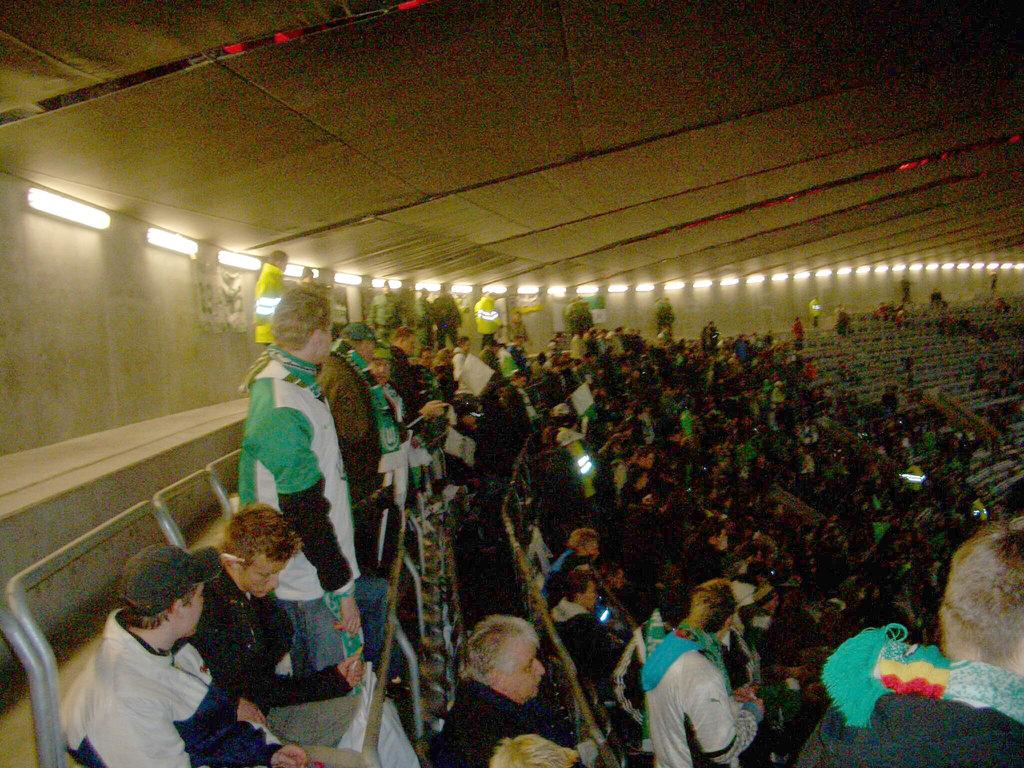What is the main subject of the image? The main subject of the image is a crowd. Can you describe the positions of the people in the crowd? Some people in the crowd are sitting, while others are standing. What can be seen on the ceiling in the image? There are lights on the ceiling. How many geese are flying above the crowd in the image? There are no geese present in the image. What type of comb is being used by the people in the crowd? There is no comb visible in the image, and we cannot determine if any of the people are using one. 